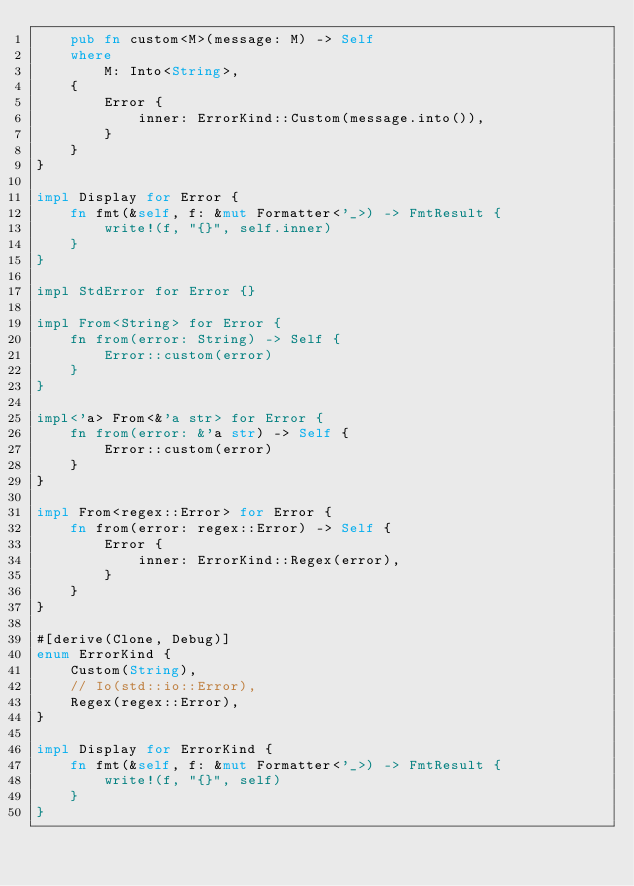<code> <loc_0><loc_0><loc_500><loc_500><_Rust_>    pub fn custom<M>(message: M) -> Self
    where
        M: Into<String>,
    {
        Error {
            inner: ErrorKind::Custom(message.into()),
        }
    }
}

impl Display for Error {
    fn fmt(&self, f: &mut Formatter<'_>) -> FmtResult {
        write!(f, "{}", self.inner)
    }
}

impl StdError for Error {}

impl From<String> for Error {
    fn from(error: String) -> Self {
        Error::custom(error)
    }
}

impl<'a> From<&'a str> for Error {
    fn from(error: &'a str) -> Self {
        Error::custom(error)
    }
}

impl From<regex::Error> for Error {
    fn from(error: regex::Error) -> Self {
        Error {
            inner: ErrorKind::Regex(error),
        }
    }
}

#[derive(Clone, Debug)]
enum ErrorKind {
    Custom(String),
    // Io(std::io::Error),
    Regex(regex::Error),
}

impl Display for ErrorKind {
    fn fmt(&self, f: &mut Formatter<'_>) -> FmtResult {
        write!(f, "{}", self)
    }
}
</code> 